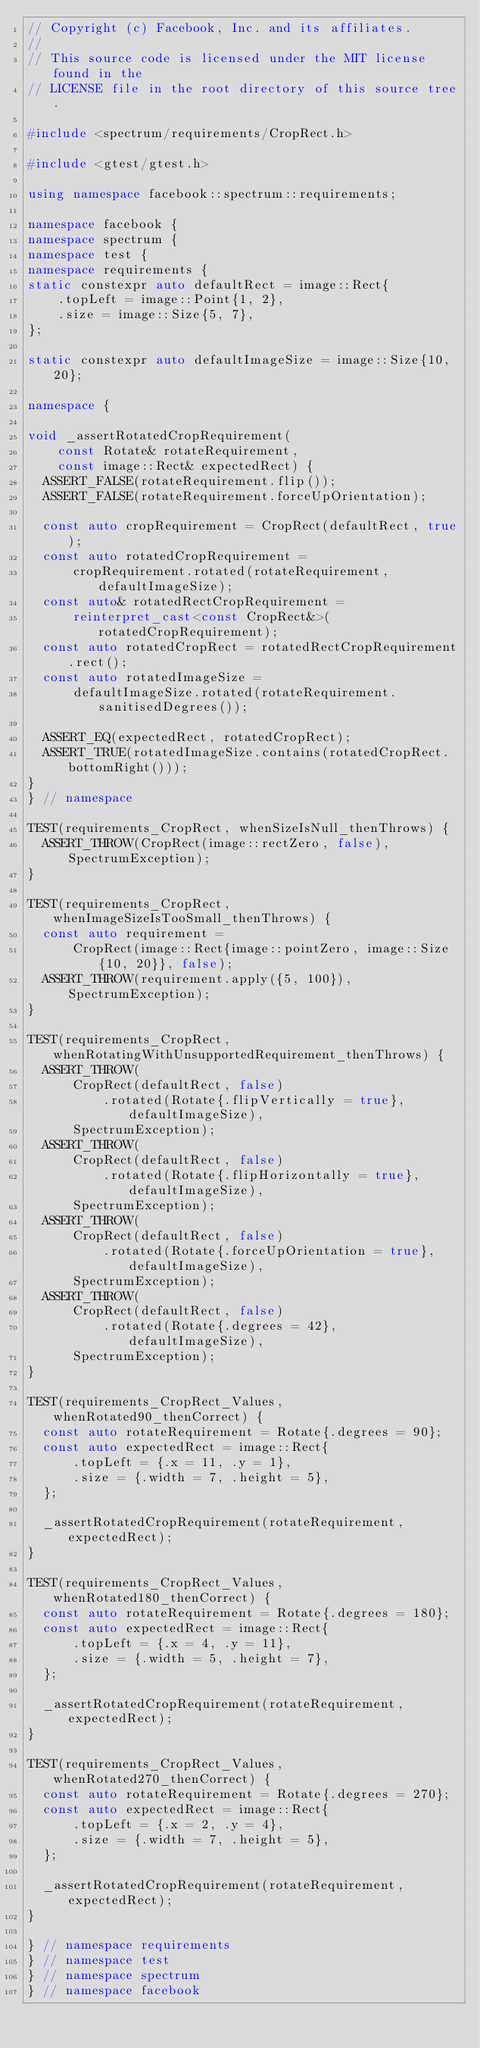<code> <loc_0><loc_0><loc_500><loc_500><_C++_>// Copyright (c) Facebook, Inc. and its affiliates.
//
// This source code is licensed under the MIT license found in the
// LICENSE file in the root directory of this source tree.

#include <spectrum/requirements/CropRect.h>

#include <gtest/gtest.h>

using namespace facebook::spectrum::requirements;

namespace facebook {
namespace spectrum {
namespace test {
namespace requirements {
static constexpr auto defaultRect = image::Rect{
    .topLeft = image::Point{1, 2},
    .size = image::Size{5, 7},
};

static constexpr auto defaultImageSize = image::Size{10, 20};

namespace {

void _assertRotatedCropRequirement(
    const Rotate& rotateRequirement,
    const image::Rect& expectedRect) {
  ASSERT_FALSE(rotateRequirement.flip());
  ASSERT_FALSE(rotateRequirement.forceUpOrientation);

  const auto cropRequirement = CropRect(defaultRect, true);
  const auto rotatedCropRequirement =
      cropRequirement.rotated(rotateRequirement, defaultImageSize);
  const auto& rotatedRectCropRequirement =
      reinterpret_cast<const CropRect&>(rotatedCropRequirement);
  const auto rotatedCropRect = rotatedRectCropRequirement.rect();
  const auto rotatedImageSize =
      defaultImageSize.rotated(rotateRequirement.sanitisedDegrees());

  ASSERT_EQ(expectedRect, rotatedCropRect);
  ASSERT_TRUE(rotatedImageSize.contains(rotatedCropRect.bottomRight()));
}
} // namespace

TEST(requirements_CropRect, whenSizeIsNull_thenThrows) {
  ASSERT_THROW(CropRect(image::rectZero, false), SpectrumException);
}

TEST(requirements_CropRect, whenImageSizeIsTooSmall_thenThrows) {
  const auto requirement =
      CropRect(image::Rect{image::pointZero, image::Size{10, 20}}, false);
  ASSERT_THROW(requirement.apply({5, 100}), SpectrumException);
}

TEST(requirements_CropRect, whenRotatingWithUnsupportedRequirement_thenThrows) {
  ASSERT_THROW(
      CropRect(defaultRect, false)
          .rotated(Rotate{.flipVertically = true}, defaultImageSize),
      SpectrumException);
  ASSERT_THROW(
      CropRect(defaultRect, false)
          .rotated(Rotate{.flipHorizontally = true}, defaultImageSize),
      SpectrumException);
  ASSERT_THROW(
      CropRect(defaultRect, false)
          .rotated(Rotate{.forceUpOrientation = true}, defaultImageSize),
      SpectrumException);
  ASSERT_THROW(
      CropRect(defaultRect, false)
          .rotated(Rotate{.degrees = 42}, defaultImageSize),
      SpectrumException);
}

TEST(requirements_CropRect_Values, whenRotated90_thenCorrect) {
  const auto rotateRequirement = Rotate{.degrees = 90};
  const auto expectedRect = image::Rect{
      .topLeft = {.x = 11, .y = 1},
      .size = {.width = 7, .height = 5},
  };

  _assertRotatedCropRequirement(rotateRequirement, expectedRect);
}

TEST(requirements_CropRect_Values, whenRotated180_thenCorrect) {
  const auto rotateRequirement = Rotate{.degrees = 180};
  const auto expectedRect = image::Rect{
      .topLeft = {.x = 4, .y = 11},
      .size = {.width = 5, .height = 7},
  };

  _assertRotatedCropRequirement(rotateRequirement, expectedRect);
}

TEST(requirements_CropRect_Values, whenRotated270_thenCorrect) {
  const auto rotateRequirement = Rotate{.degrees = 270};
  const auto expectedRect = image::Rect{
      .topLeft = {.x = 2, .y = 4},
      .size = {.width = 7, .height = 5},
  };

  _assertRotatedCropRequirement(rotateRequirement, expectedRect);
}

} // namespace requirements
} // namespace test
} // namespace spectrum
} // namespace facebook
</code> 